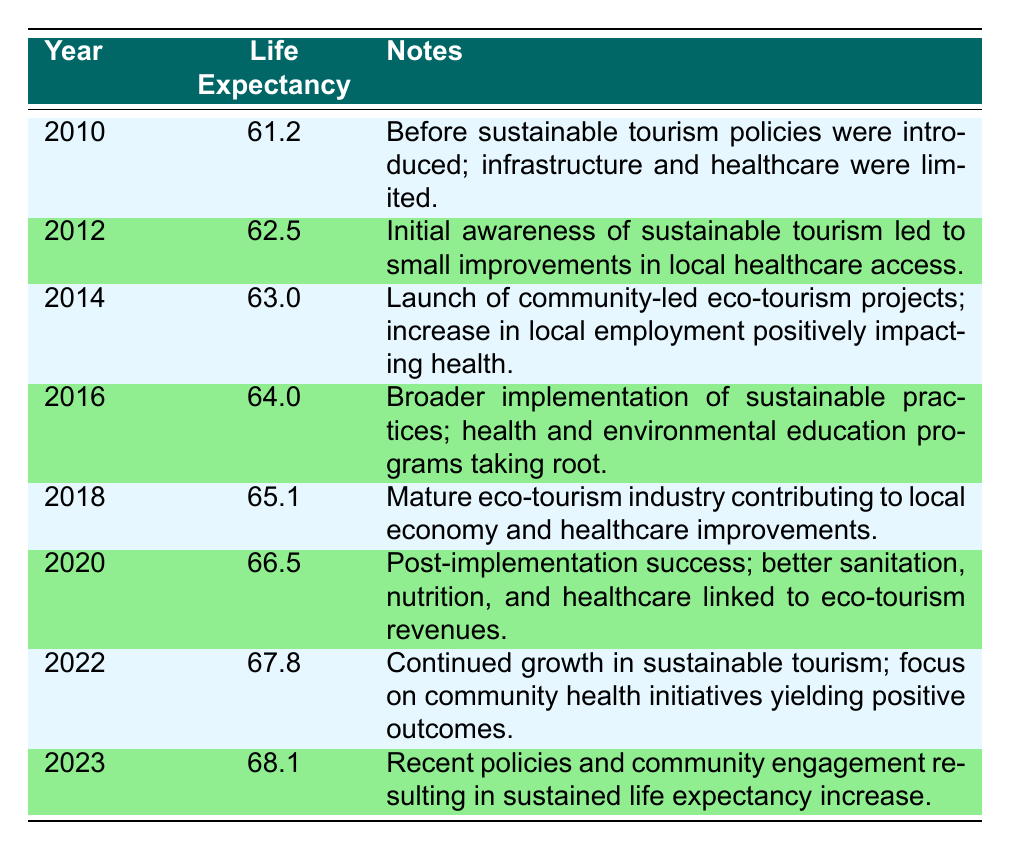What was the life expectancy in 2010? The table shows that in the year 2010, the life expectancy was 61.2.
Answer: 61.2 What was the life expectancy change from 2010 to 2022? The life expectancy in 2010 was 61.2, and in 2022 it was 67.8. The change is calculated as 67.8 - 61.2 = 6.6 years.
Answer: 6.6 years True or False: The life expectancy in 2014 was higher than in 2012. In 2014, the life expectancy was 63.0, while in 2012 it was 62.5. Since 63.0 is greater than 62.5, the statement is true.
Answer: True What is the average life expectancy between the years 2016 and 2023? The life expectancies for those years are 64.0 (2016), 65.1 (2018), 66.5 (2020), 67.8 (2022), and 68.1 (2023). Adding them gives: 64.0 + 65.1 + 66.5 + 67.8 + 68.1 = 331.5. There are 5 data points, so the average is 331.5 / 5 = 66.3.
Answer: 66.3 How much did the life expectancy increase from 2018 to 2020? The life expectancy in 2018 was 65.1, and in 2020 it was 66.5. The increase is calculated as 66.5 - 65.1 = 1.4 years.
Answer: 1.4 years 